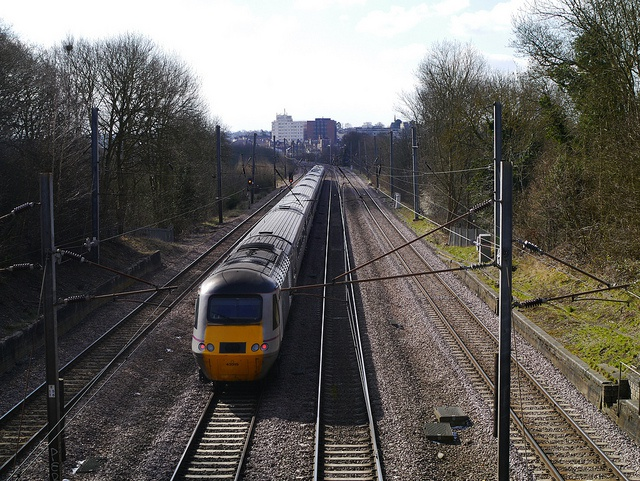Describe the objects in this image and their specific colors. I can see a train in white, black, gray, darkgray, and maroon tones in this image. 